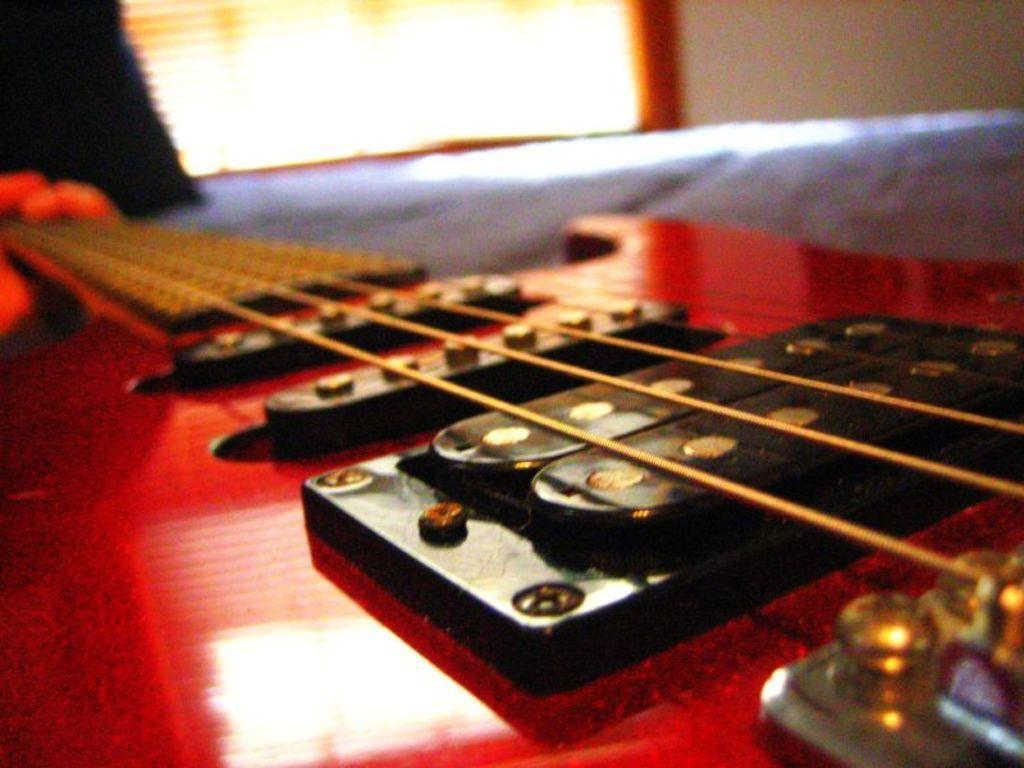Can you describe this image briefly? This is a guitar and we can clearly see strings also. In the background there is a wall. 